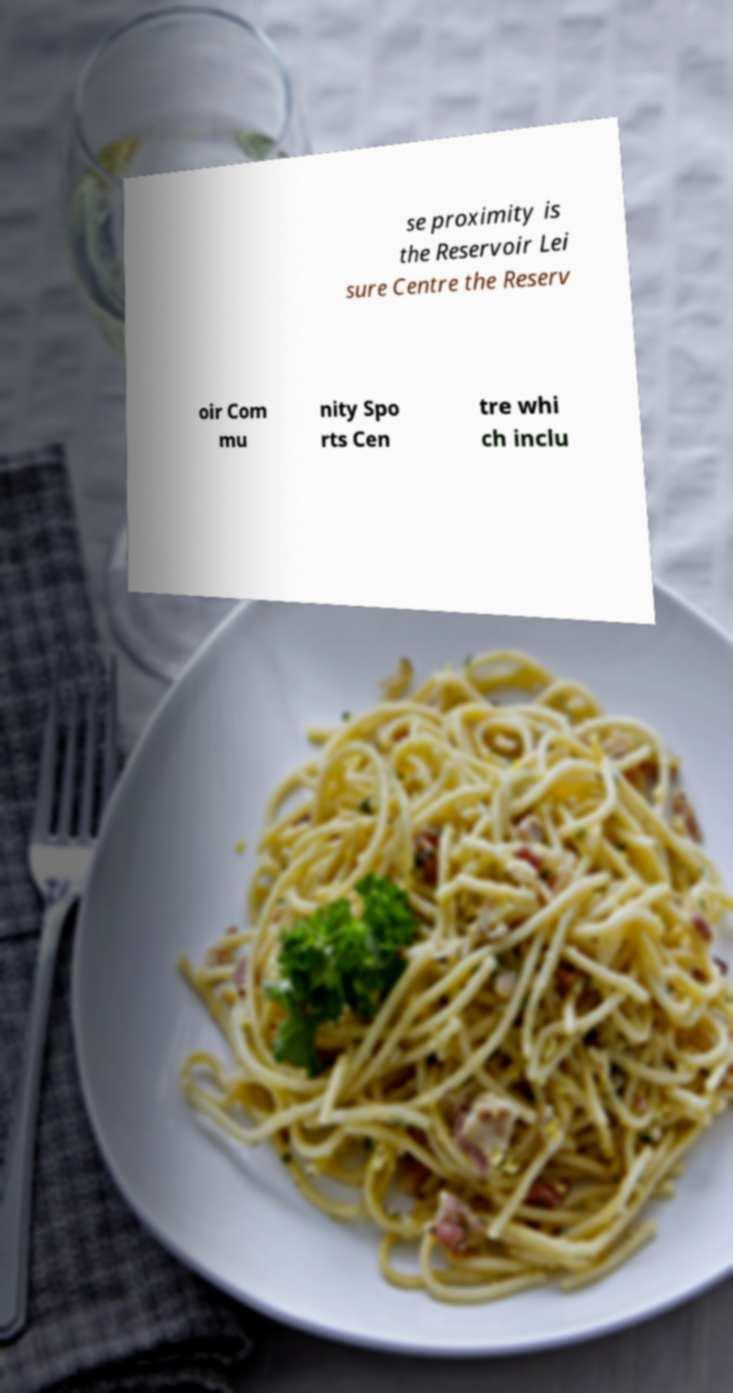Can you accurately transcribe the text from the provided image for me? se proximity is the Reservoir Lei sure Centre the Reserv oir Com mu nity Spo rts Cen tre whi ch inclu 